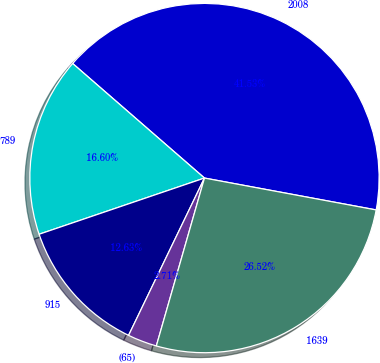Convert chart to OTSL. <chart><loc_0><loc_0><loc_500><loc_500><pie_chart><fcel>2008<fcel>789<fcel>915<fcel>(65)<fcel>1639<nl><fcel>41.53%<fcel>16.6%<fcel>12.63%<fcel>2.71%<fcel>26.52%<nl></chart> 